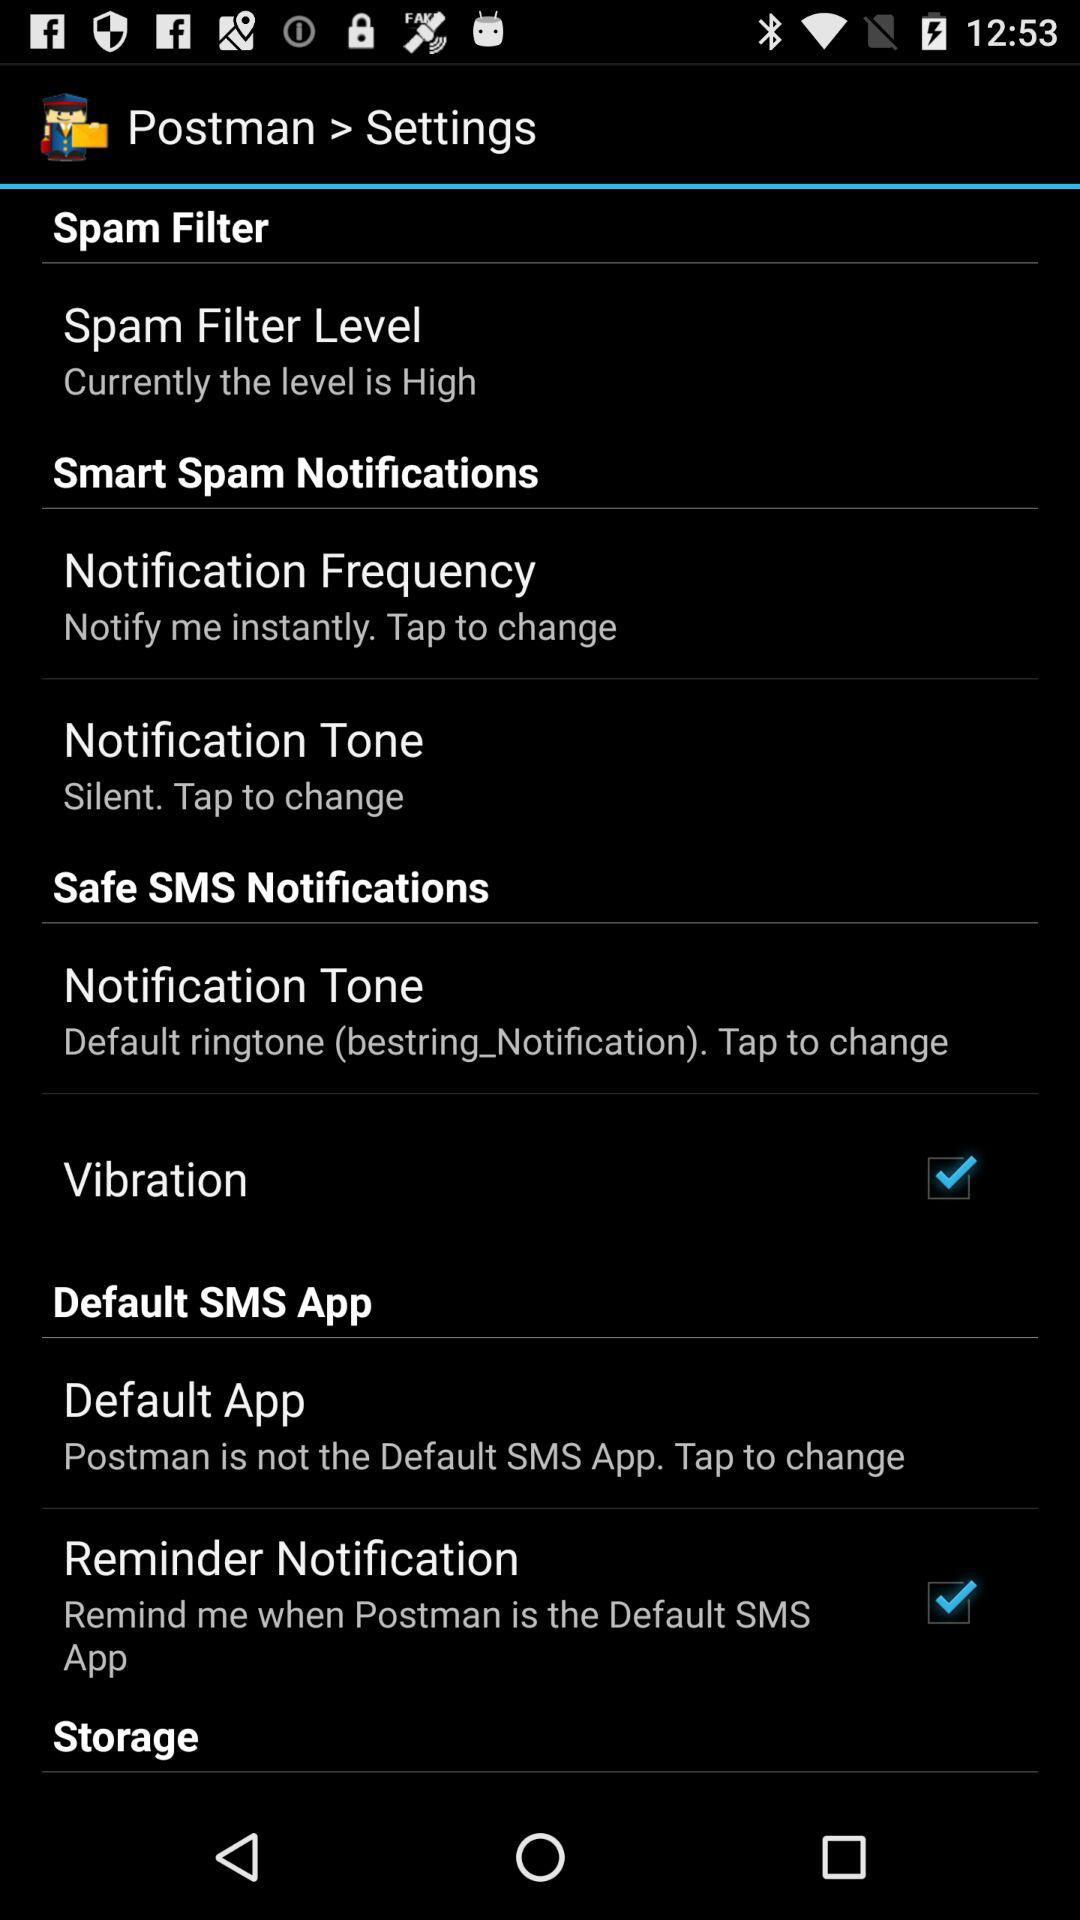What is the spam notification tone? The spam notification tone is "Silent". 